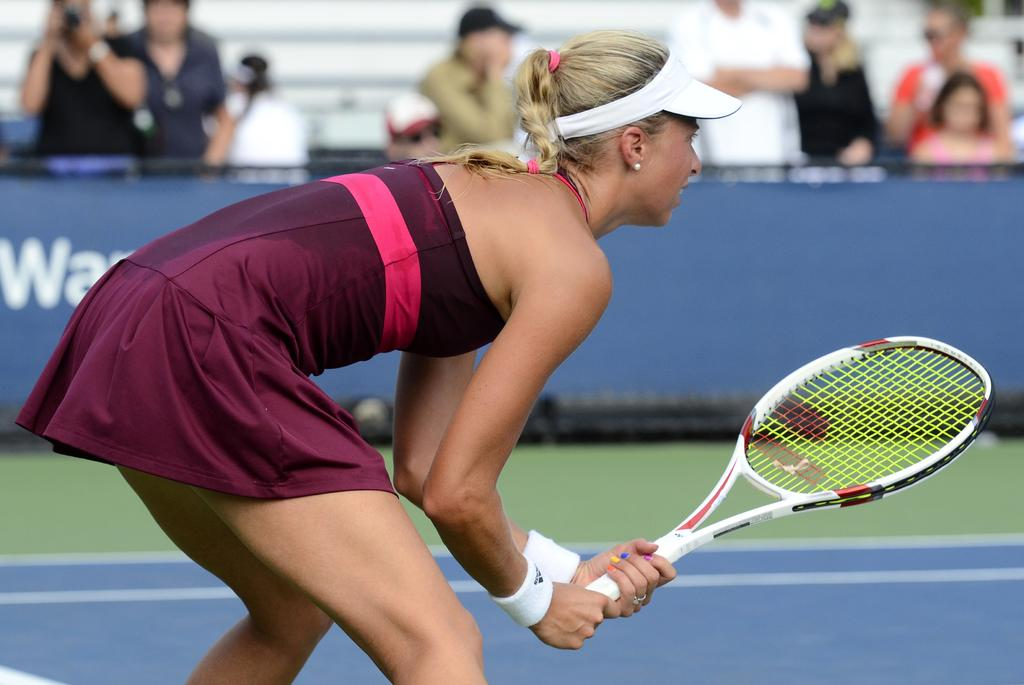Who is the main subject in the image? There is a woman in the center of the image. What is the woman doing in the image? The woman is standing and holding a tennis racket in her hands. Are there any other people visible in the image? Yes, there are people standing in the background of the image. What type of engine can be seen in the image? There is no engine present in the image. Are there any flowers visible in the image? There is no mention of flowers in the provided facts, so we cannot determine if any are present in the image. 